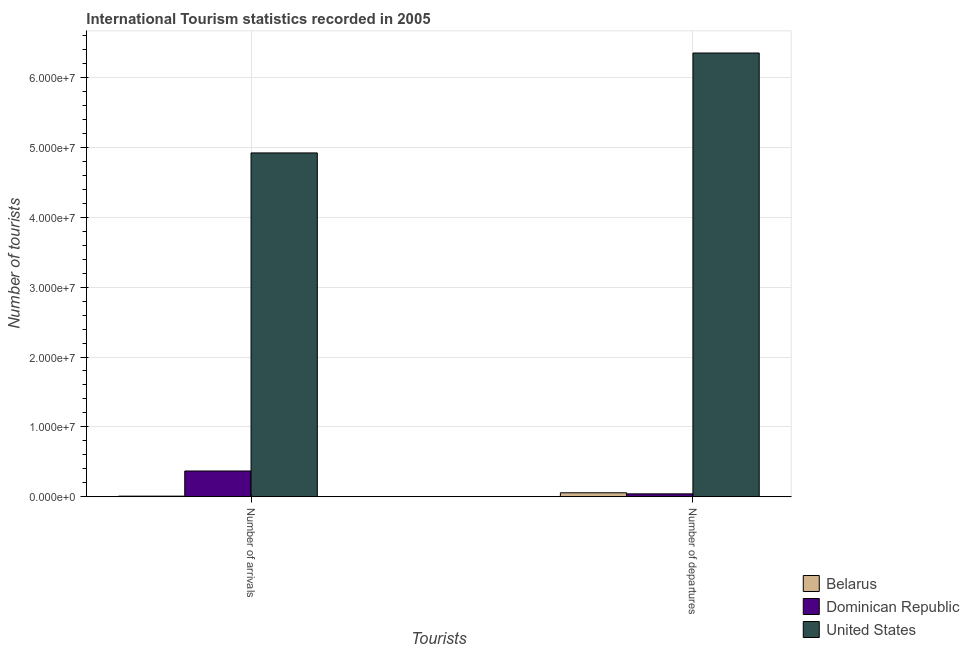How many different coloured bars are there?
Your answer should be compact. 3. Are the number of bars on each tick of the X-axis equal?
Your answer should be compact. Yes. How many bars are there on the 1st tick from the left?
Offer a very short reply. 3. What is the label of the 2nd group of bars from the left?
Your answer should be very brief. Number of departures. What is the number of tourist arrivals in United States?
Ensure brevity in your answer.  4.92e+07. Across all countries, what is the maximum number of tourist departures?
Your answer should be compact. 6.35e+07. Across all countries, what is the minimum number of tourist arrivals?
Your response must be concise. 9.10e+04. In which country was the number of tourist departures minimum?
Offer a terse response. Dominican Republic. What is the total number of tourist arrivals in the graph?
Offer a very short reply. 5.30e+07. What is the difference between the number of tourist departures in United States and that in Belarus?
Ensure brevity in your answer.  6.29e+07. What is the difference between the number of tourist arrivals in Belarus and the number of tourist departures in Dominican Republic?
Offer a very short reply. -3.28e+05. What is the average number of tourist arrivals per country?
Make the answer very short. 1.77e+07. What is the difference between the number of tourist arrivals and number of tourist departures in United States?
Offer a very short reply. -1.43e+07. What is the ratio of the number of tourist departures in Dominican Republic to that in Belarus?
Give a very brief answer. 0.73. In how many countries, is the number of tourist arrivals greater than the average number of tourist arrivals taken over all countries?
Offer a very short reply. 1. What does the 2nd bar from the left in Number of arrivals represents?
Your answer should be very brief. Dominican Republic. What does the 3rd bar from the right in Number of arrivals represents?
Offer a terse response. Belarus. Are the values on the major ticks of Y-axis written in scientific E-notation?
Provide a short and direct response. Yes. Where does the legend appear in the graph?
Offer a very short reply. Bottom right. How many legend labels are there?
Provide a succinct answer. 3. What is the title of the graph?
Your response must be concise. International Tourism statistics recorded in 2005. What is the label or title of the X-axis?
Provide a short and direct response. Tourists. What is the label or title of the Y-axis?
Your answer should be very brief. Number of tourists. What is the Number of tourists in Belarus in Number of arrivals?
Make the answer very short. 9.10e+04. What is the Number of tourists of Dominican Republic in Number of arrivals?
Give a very brief answer. 3.69e+06. What is the Number of tourists in United States in Number of arrivals?
Provide a succinct answer. 4.92e+07. What is the Number of tourists in Belarus in Number of departures?
Provide a succinct answer. 5.72e+05. What is the Number of tourists of Dominican Republic in Number of departures?
Keep it short and to the point. 4.19e+05. What is the Number of tourists in United States in Number of departures?
Your answer should be compact. 6.35e+07. Across all Tourists, what is the maximum Number of tourists of Belarus?
Give a very brief answer. 5.72e+05. Across all Tourists, what is the maximum Number of tourists of Dominican Republic?
Your answer should be very brief. 3.69e+06. Across all Tourists, what is the maximum Number of tourists in United States?
Offer a very short reply. 6.35e+07. Across all Tourists, what is the minimum Number of tourists of Belarus?
Your answer should be compact. 9.10e+04. Across all Tourists, what is the minimum Number of tourists of Dominican Republic?
Keep it short and to the point. 4.19e+05. Across all Tourists, what is the minimum Number of tourists in United States?
Your answer should be very brief. 4.92e+07. What is the total Number of tourists of Belarus in the graph?
Keep it short and to the point. 6.63e+05. What is the total Number of tourists in Dominican Republic in the graph?
Provide a succinct answer. 4.11e+06. What is the total Number of tourists in United States in the graph?
Give a very brief answer. 1.13e+08. What is the difference between the Number of tourists in Belarus in Number of arrivals and that in Number of departures?
Provide a short and direct response. -4.81e+05. What is the difference between the Number of tourists in Dominican Republic in Number of arrivals and that in Number of departures?
Your answer should be very brief. 3.27e+06. What is the difference between the Number of tourists in United States in Number of arrivals and that in Number of departures?
Your answer should be compact. -1.43e+07. What is the difference between the Number of tourists of Belarus in Number of arrivals and the Number of tourists of Dominican Republic in Number of departures?
Make the answer very short. -3.28e+05. What is the difference between the Number of tourists in Belarus in Number of arrivals and the Number of tourists in United States in Number of departures?
Keep it short and to the point. -6.34e+07. What is the difference between the Number of tourists in Dominican Republic in Number of arrivals and the Number of tourists in United States in Number of departures?
Your answer should be very brief. -5.98e+07. What is the average Number of tourists in Belarus per Tourists?
Keep it short and to the point. 3.32e+05. What is the average Number of tourists in Dominican Republic per Tourists?
Make the answer very short. 2.06e+06. What is the average Number of tourists in United States per Tourists?
Offer a very short reply. 5.64e+07. What is the difference between the Number of tourists in Belarus and Number of tourists in Dominican Republic in Number of arrivals?
Give a very brief answer. -3.60e+06. What is the difference between the Number of tourists in Belarus and Number of tourists in United States in Number of arrivals?
Your answer should be compact. -4.91e+07. What is the difference between the Number of tourists in Dominican Republic and Number of tourists in United States in Number of arrivals?
Keep it short and to the point. -4.55e+07. What is the difference between the Number of tourists in Belarus and Number of tourists in Dominican Republic in Number of departures?
Your response must be concise. 1.53e+05. What is the difference between the Number of tourists of Belarus and Number of tourists of United States in Number of departures?
Give a very brief answer. -6.29e+07. What is the difference between the Number of tourists of Dominican Republic and Number of tourists of United States in Number of departures?
Give a very brief answer. -6.31e+07. What is the ratio of the Number of tourists in Belarus in Number of arrivals to that in Number of departures?
Keep it short and to the point. 0.16. What is the ratio of the Number of tourists of Dominican Republic in Number of arrivals to that in Number of departures?
Give a very brief answer. 8.81. What is the ratio of the Number of tourists of United States in Number of arrivals to that in Number of departures?
Give a very brief answer. 0.77. What is the difference between the highest and the second highest Number of tourists of Belarus?
Your answer should be compact. 4.81e+05. What is the difference between the highest and the second highest Number of tourists of Dominican Republic?
Offer a very short reply. 3.27e+06. What is the difference between the highest and the second highest Number of tourists of United States?
Keep it short and to the point. 1.43e+07. What is the difference between the highest and the lowest Number of tourists of Belarus?
Give a very brief answer. 4.81e+05. What is the difference between the highest and the lowest Number of tourists of Dominican Republic?
Provide a short and direct response. 3.27e+06. What is the difference between the highest and the lowest Number of tourists of United States?
Ensure brevity in your answer.  1.43e+07. 